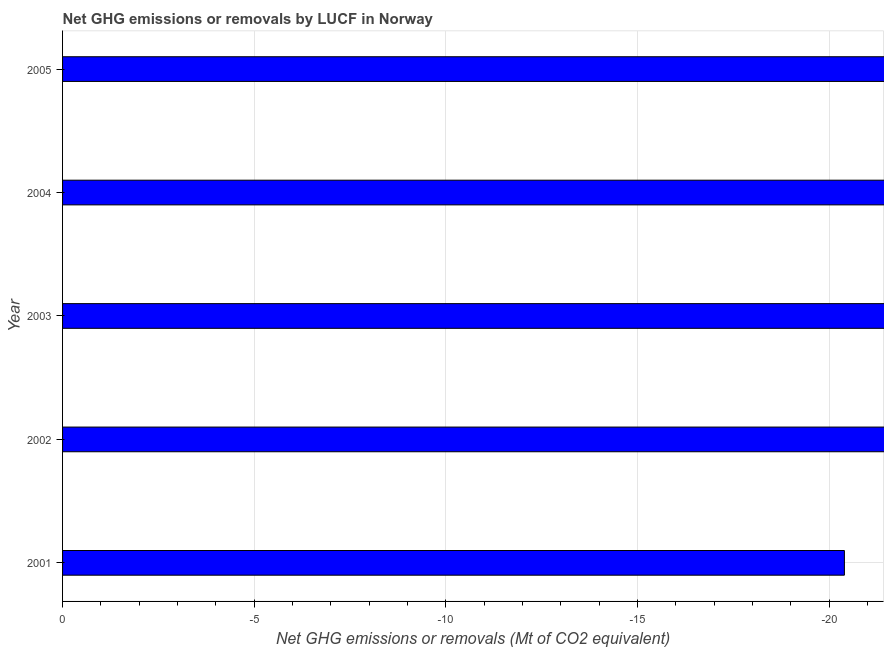Does the graph contain grids?
Your response must be concise. Yes. What is the title of the graph?
Your answer should be very brief. Net GHG emissions or removals by LUCF in Norway. What is the label or title of the X-axis?
Offer a terse response. Net GHG emissions or removals (Mt of CO2 equivalent). Across all years, what is the minimum ghg net emissions or removals?
Offer a very short reply. 0. What is the sum of the ghg net emissions or removals?
Offer a very short reply. 0. In how many years, is the ghg net emissions or removals greater than the average ghg net emissions or removals taken over all years?
Provide a short and direct response. 0. How many years are there in the graph?
Your answer should be compact. 5. What is the difference between two consecutive major ticks on the X-axis?
Keep it short and to the point. 5. Are the values on the major ticks of X-axis written in scientific E-notation?
Your answer should be very brief. No. What is the Net GHG emissions or removals (Mt of CO2 equivalent) in 2001?
Your response must be concise. 0. What is the Net GHG emissions or removals (Mt of CO2 equivalent) in 2002?
Offer a very short reply. 0. What is the Net GHG emissions or removals (Mt of CO2 equivalent) in 2003?
Make the answer very short. 0. 